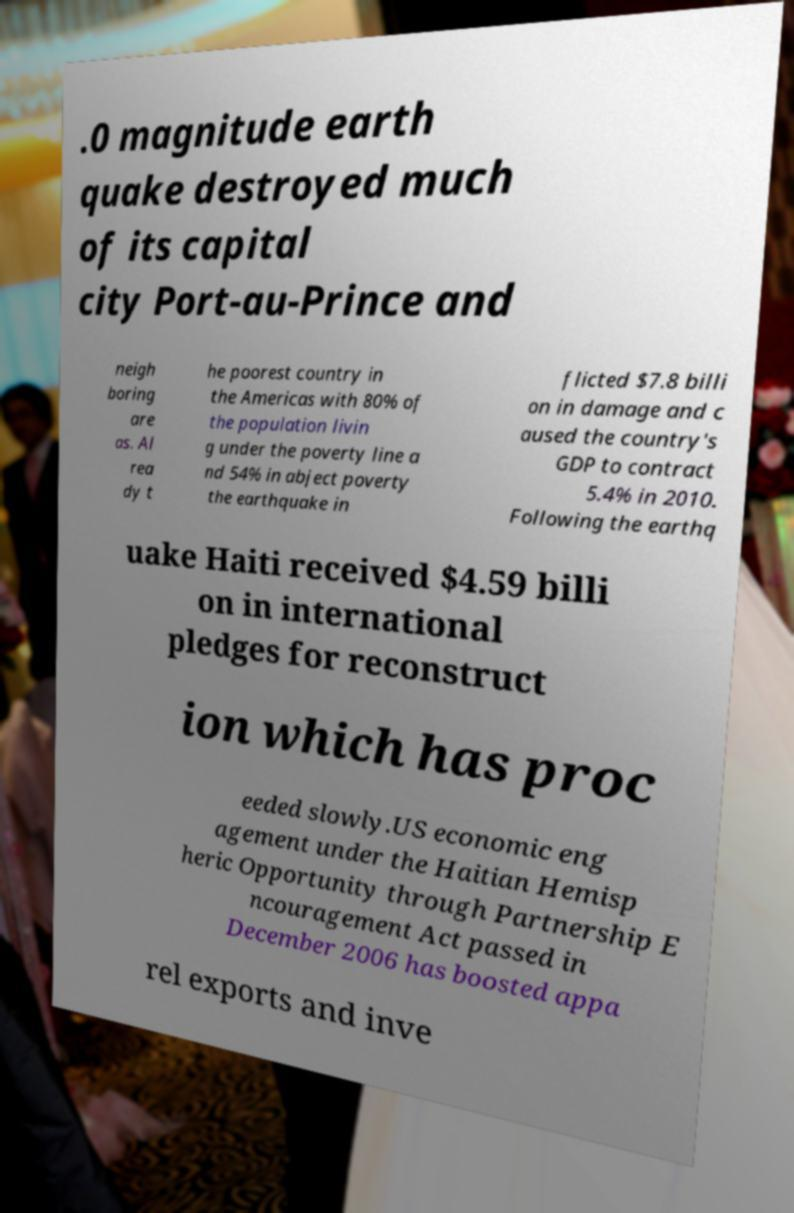Please identify and transcribe the text found in this image. .0 magnitude earth quake destroyed much of its capital city Port-au-Prince and neigh boring are as. Al rea dy t he poorest country in the Americas with 80% of the population livin g under the poverty line a nd 54% in abject poverty the earthquake in flicted $7.8 billi on in damage and c aused the country's GDP to contract 5.4% in 2010. Following the earthq uake Haiti received $4.59 billi on in international pledges for reconstruct ion which has proc eeded slowly.US economic eng agement under the Haitian Hemisp heric Opportunity through Partnership E ncouragement Act passed in December 2006 has boosted appa rel exports and inve 